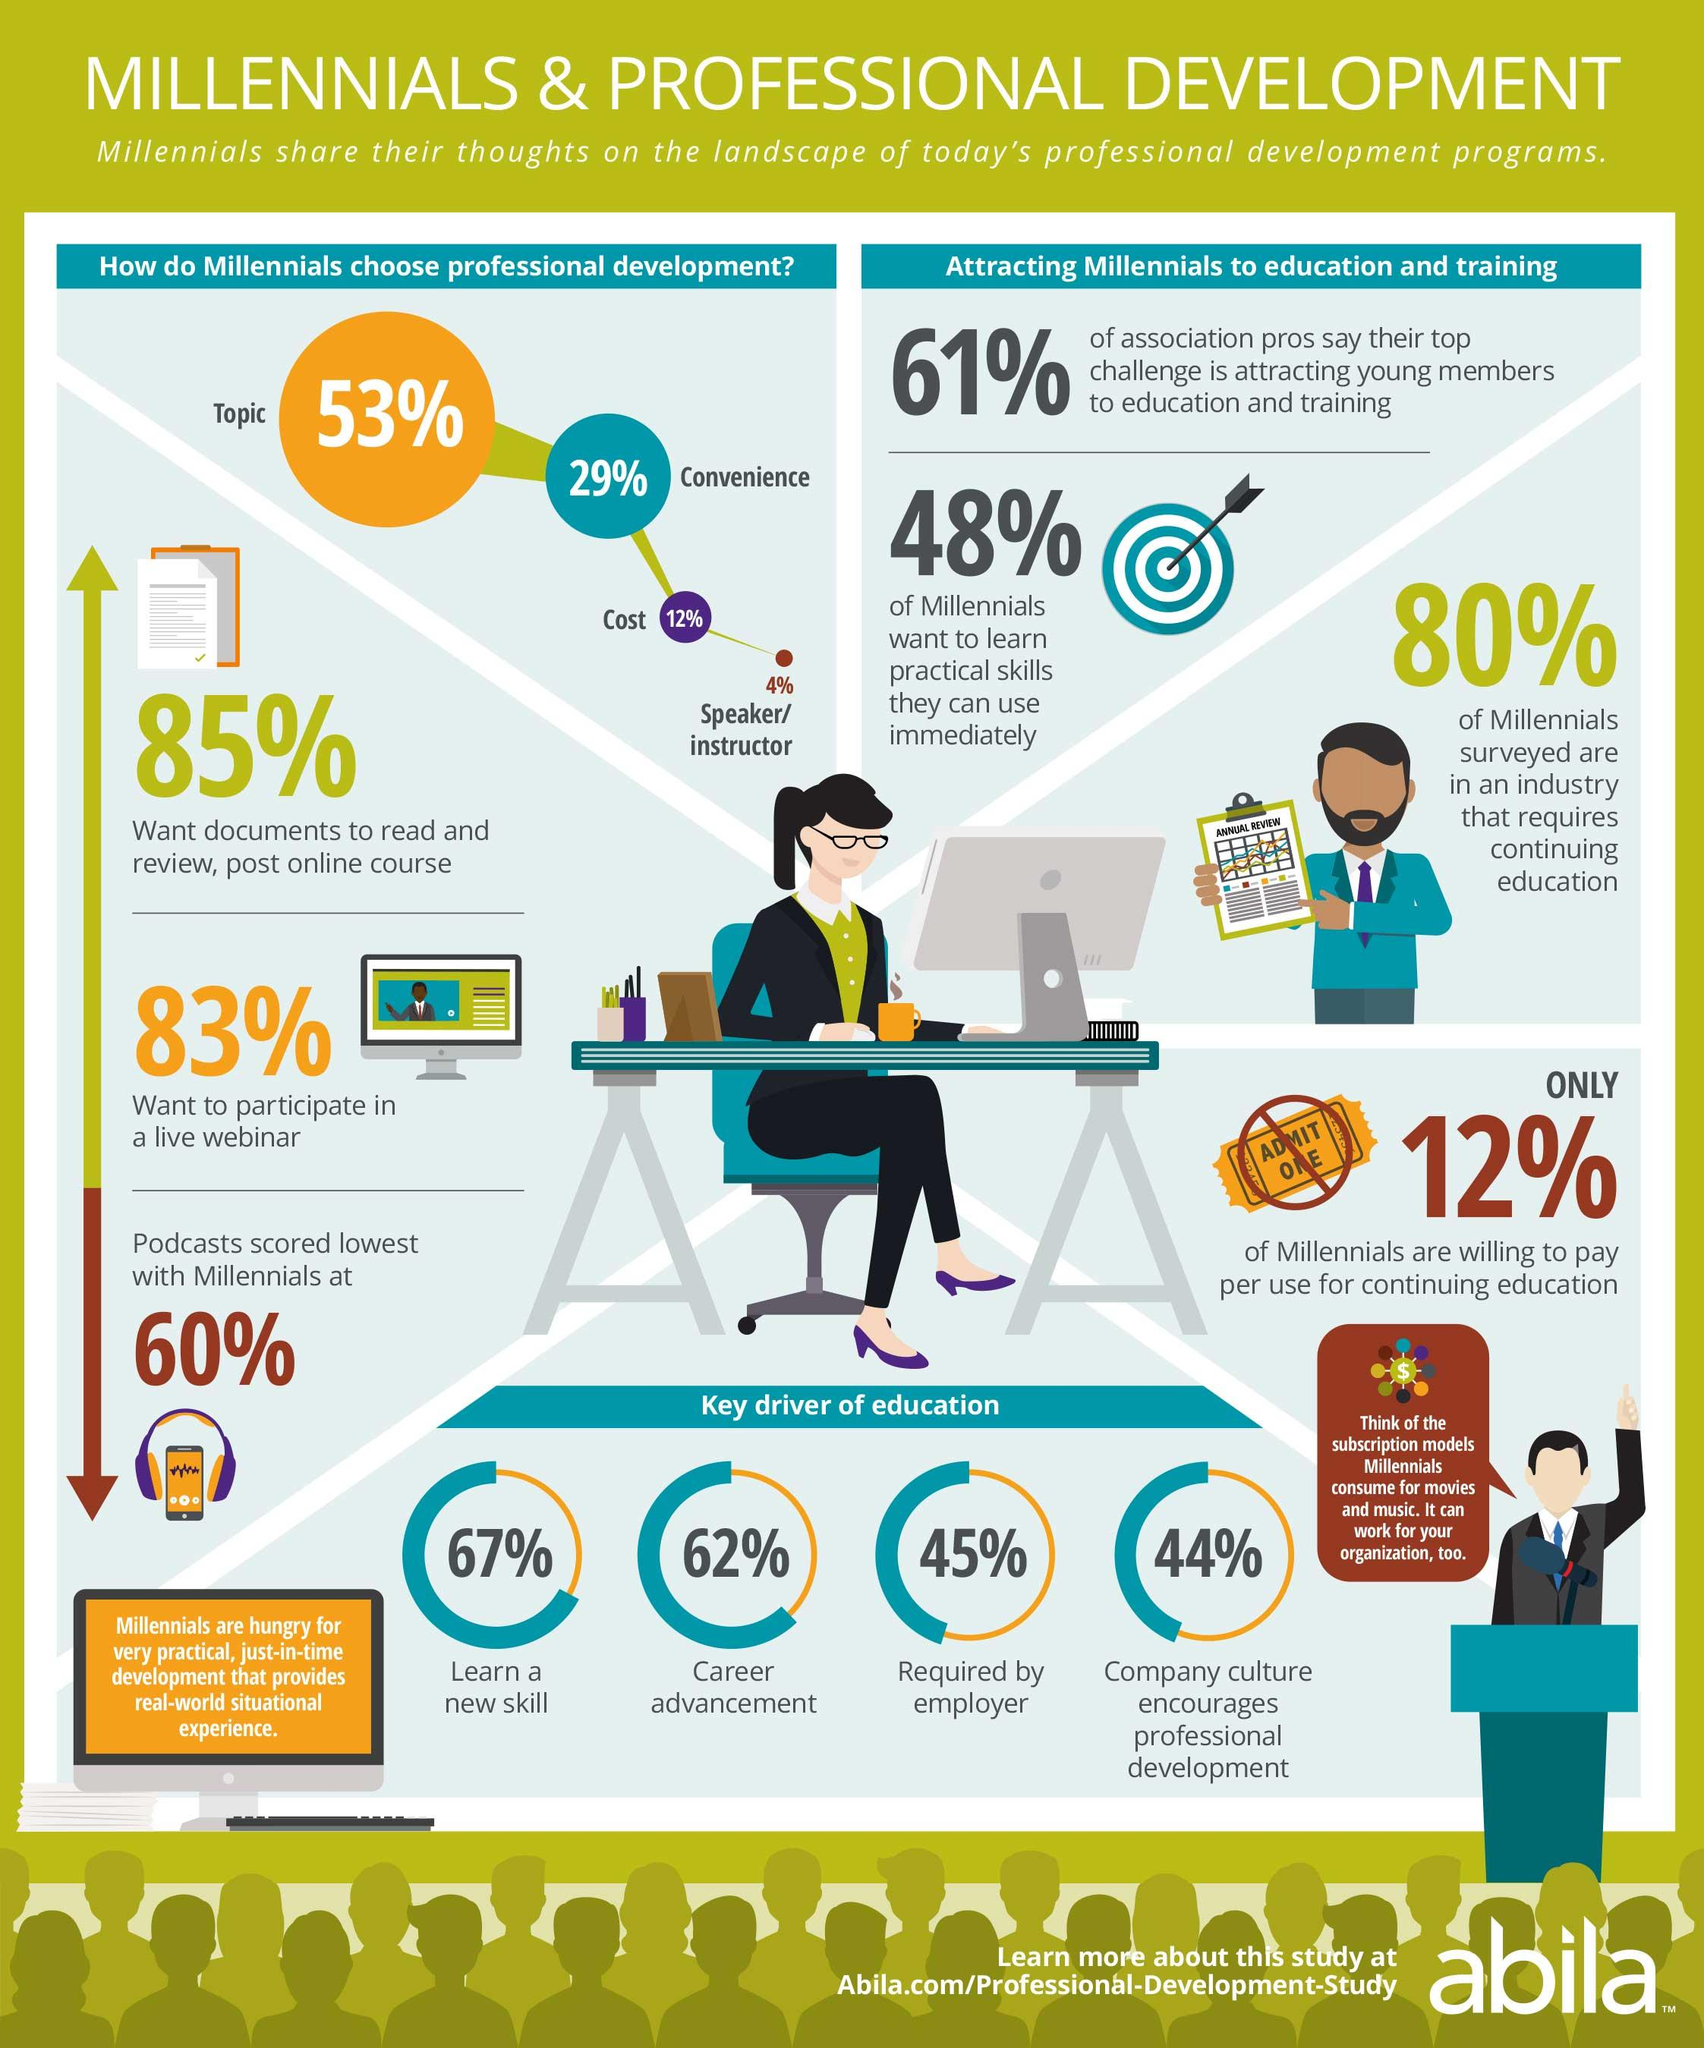Give some essential details in this illustration. It is estimated that 88% of millennials are not willing to pay per use for continuing education. According to the survey, 60% of millennials use podcasts. According to a survey, 17% of millennials do not want to participate in a live webinar. According to a survey, 67% of millennials expressed a desire to learn a new skill. According to a recent survey, 85% of millennials require access to documents in order to read and review content for online courses. 